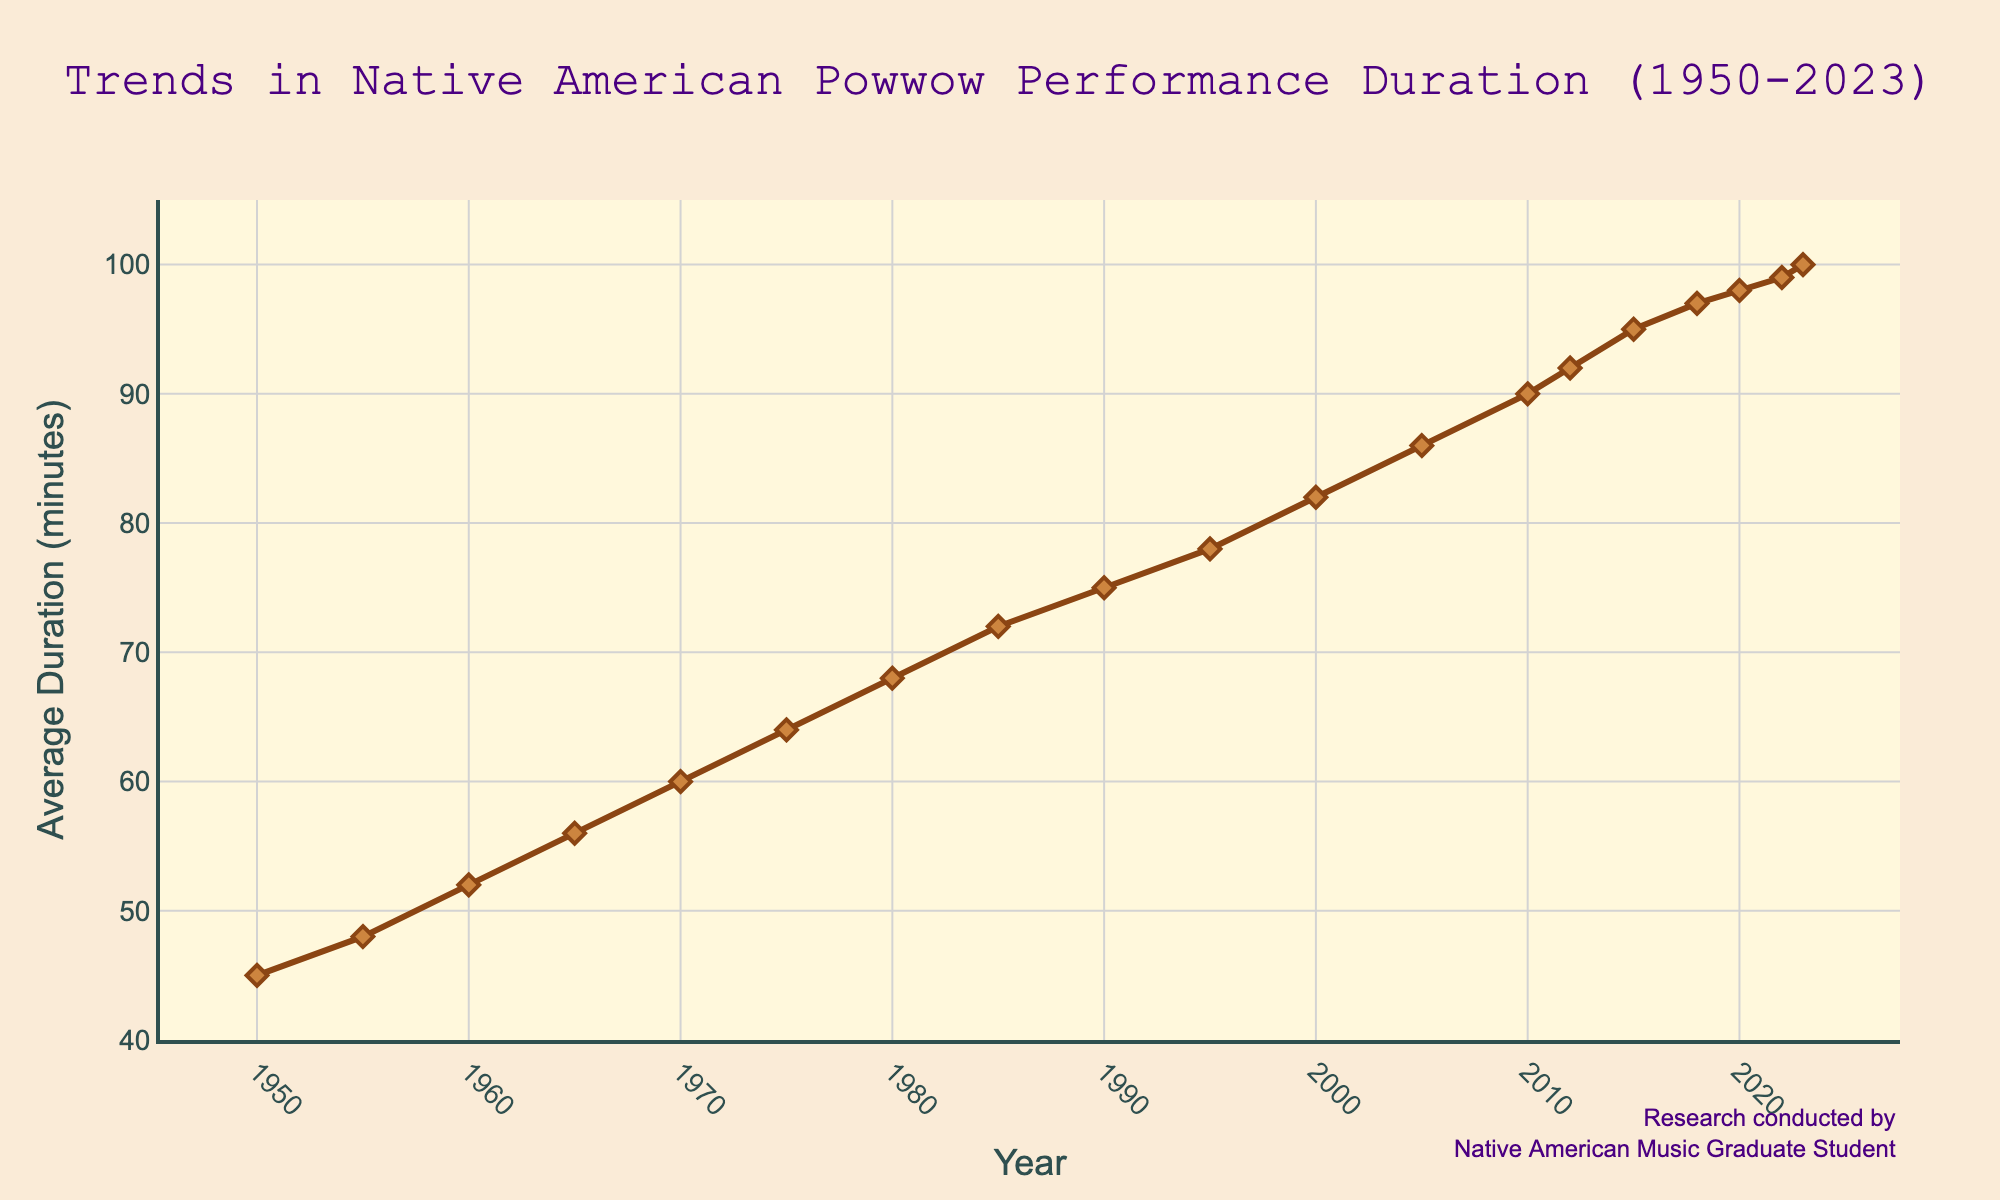What is the trend in the average duration of Native American powwow performances from 1950 to 2023? The line chart shows an increasing trend. Starting from 45 minutes in 1950, it rises steadily to 100 minutes in 2023.
Answer: An increasing trend Which decade saw the most significant increase in the average duration of powwow performances? By comparing the slopes of the line segments between each decade, the most significant increase appears between the 1960s and 1970s, increasing by 8 minutes (52 to 60).
Answer: 1960s to 1970s What was the average duration of powwow performances in 1980? Detailed inspection of the data points at 1980 indicates a value of 68 minutes.
Answer: 68 minutes By how many minutes did the average duration of performances increase from 1950 to 2000? Subtracting the 1950 value (45 minutes) from the 2000 value (82 minutes) gives a 37-minute increase.
Answer: 37 minutes During which years did the average duration cross the 90-minute mark? Referring to the values, the averages reach and exceed 90 minutes starting in 2010 (90 minutes).
Answer: 2010 What is the difference in the average duration between the years 2010 and 2023? The average duration in 2010 was 90 minutes and in 2023 was 100 minutes. Therefore, subtracting 90 from 100 yields 10 minutes.
Answer: 10 minutes Which year had an average duration closest to 80 minutes? Checking the data points, 1995 has an average duration of 78 minutes, which is the closest to 80 minutes.
Answer: 1995 How does the average duration in 1990 compare to that in 2020? The average duration in 1990 is 75 minutes, while in 2020, it is 98 minutes. The duration in 2020 is greater than in 1990.
Answer: Greater in 2020 What is the overall range of the average duration values from 1950 to 2023? The difference between the maximum value (100 minutes in 2023) and the minimum value (45 minutes in 1950) provides the range, which is 100 - 45 = 55 minutes.
Answer: 55 minutes Which years had an average duration greater than 95 minutes? From the data points, the years 2015 (95 minutes), 2018 (97 minutes), 2020 (98 minutes), 2022 (99 minutes), and 2023 (100 minutes) had average durations greater than 95 minutes.
Answer: 2015, 2018, 2020, 2022, 2023 